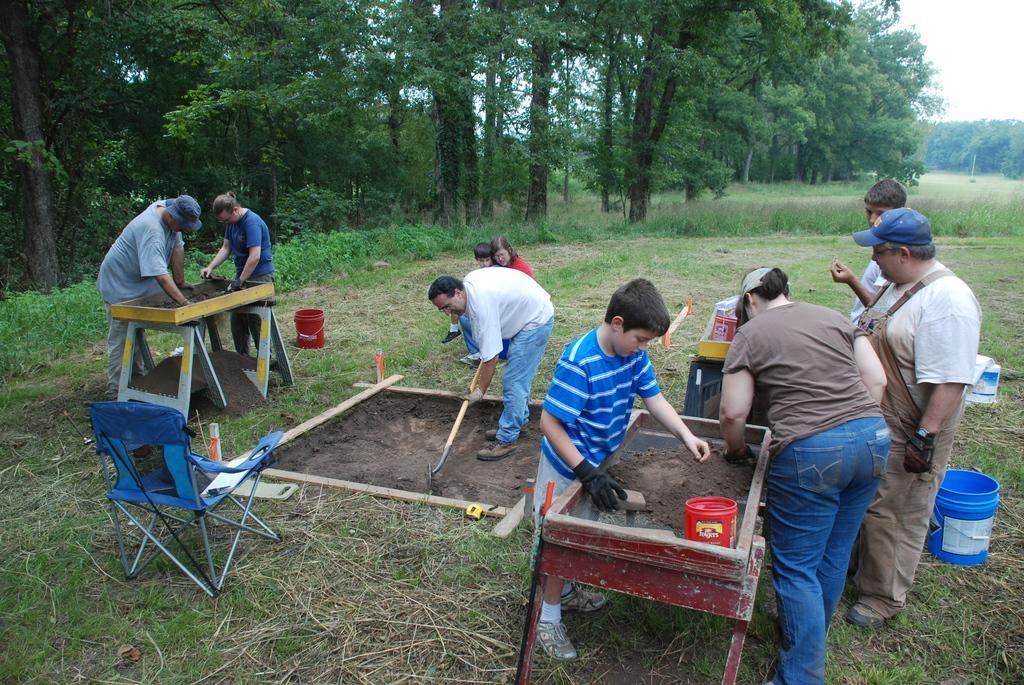How would you summarize this image in a sentence or two? On the right side of the we can man sieving the mud and persons standing on the ground. On the left side of the image we can see person digging a ground and persons sieving the mud. At the bottom we can see a chair. In the background there are trees, plants and sky. 